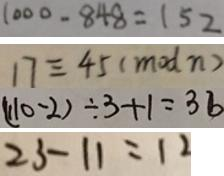<formula> <loc_0><loc_0><loc_500><loc_500>1 0 0 0 - 8 4 8 = 1 5 2 
 1 7 \equiv 4 5 ( m o d n ) 
 ( 1 1 0 - 2 ) \div 3 + 1 = 3 6 
 2 3 - 1 1 = 1 2</formula> 